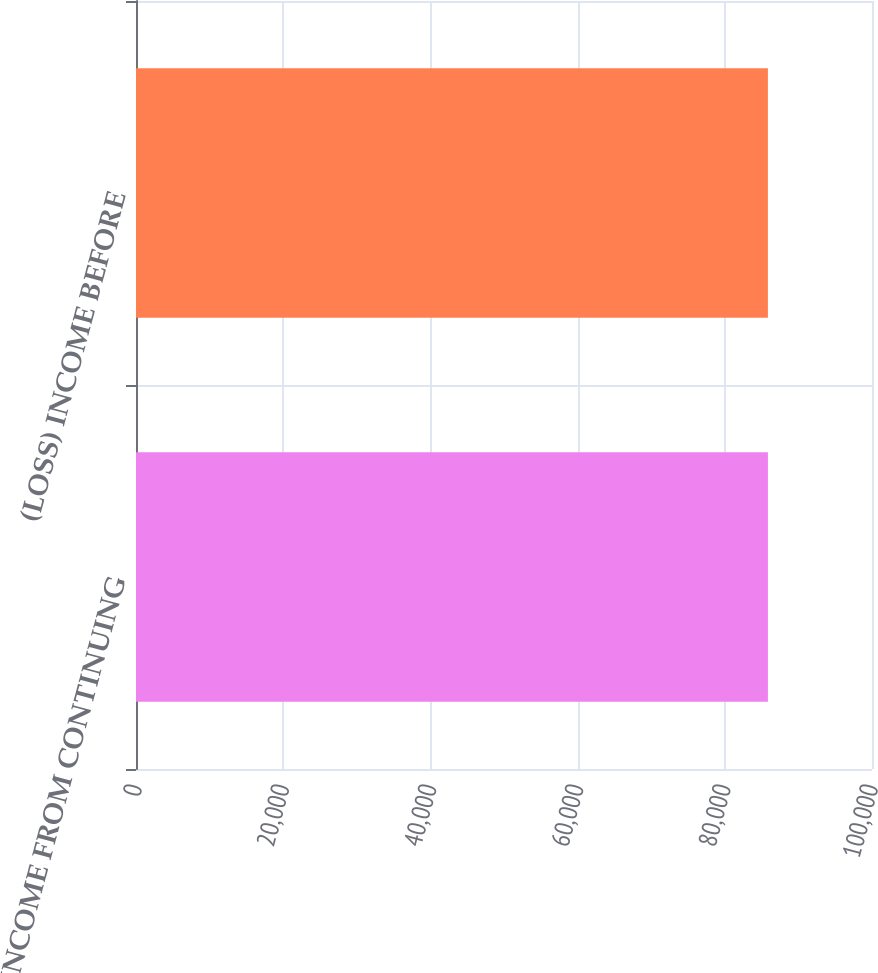Convert chart. <chart><loc_0><loc_0><loc_500><loc_500><bar_chart><fcel>(LOSS) INCOME FROM CONTINUING<fcel>(LOSS) INCOME BEFORE<nl><fcel>85857<fcel>85857.1<nl></chart> 